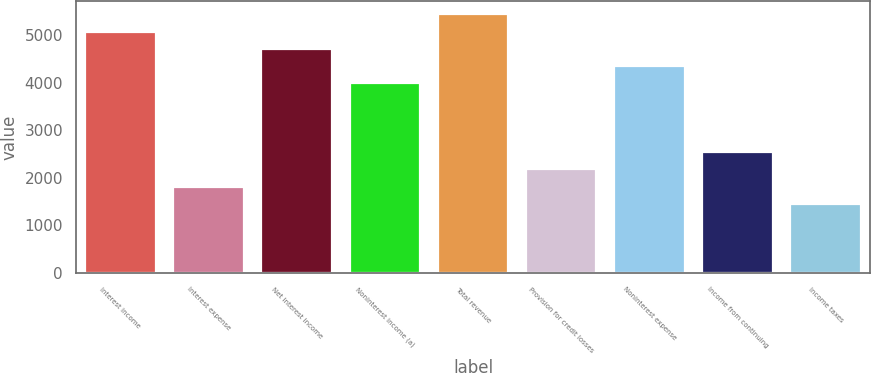Convert chart. <chart><loc_0><loc_0><loc_500><loc_500><bar_chart><fcel>Interest income<fcel>Interest expense<fcel>Net interest income<fcel>Noninterest income (a)<fcel>Total revenue<fcel>Provision for credit losses<fcel>Noninterest expense<fcel>Income from continuing<fcel>Income taxes<nl><fcel>5082.75<fcel>1816.29<fcel>4719.81<fcel>3993.93<fcel>5445.69<fcel>2179.23<fcel>4356.87<fcel>2542.17<fcel>1453.35<nl></chart> 